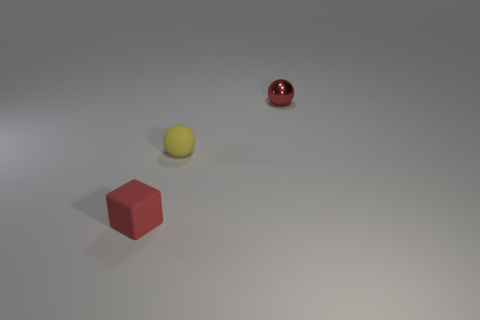There is a small yellow rubber ball; are there any objects in front of it?
Provide a short and direct response. Yes. The small red matte object has what shape?
Provide a succinct answer. Cube. What number of objects are either things that are in front of the red shiny sphere or large purple matte balls?
Your response must be concise. 2. What number of other objects are there of the same color as the small matte sphere?
Your response must be concise. 0. Is the color of the small rubber block the same as the tiny ball in front of the tiny red sphere?
Your response must be concise. No. What is the color of the other shiny thing that is the same shape as the yellow thing?
Give a very brief answer. Red. Is the red block made of the same material as the small red thing on the right side of the rubber cube?
Your response must be concise. No. What color is the tiny rubber block?
Your answer should be compact. Red. There is a small rubber thing that is behind the tiny object that is on the left side of the tiny matte object behind the small cube; what color is it?
Your response must be concise. Yellow. Is the shape of the small yellow matte object the same as the red thing in front of the yellow matte ball?
Your answer should be very brief. No. 